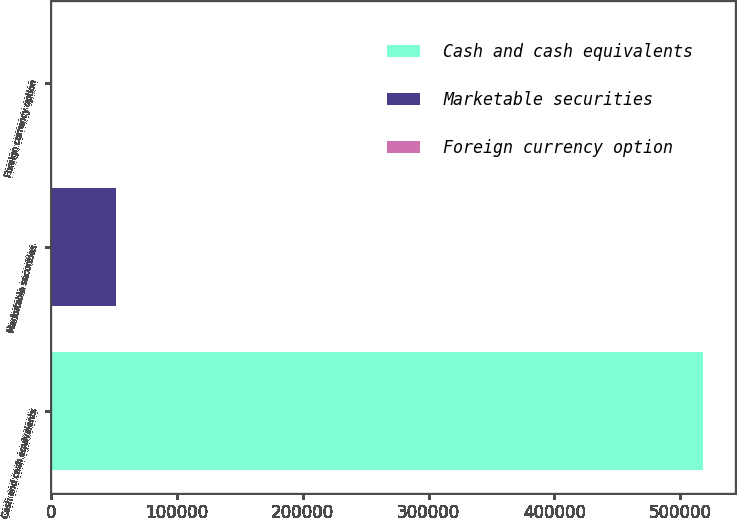<chart> <loc_0><loc_0><loc_500><loc_500><bar_chart><fcel>Cash and cash equivalents<fcel>Marketable securities<fcel>Foreign currency option<nl><fcel>517654<fcel>51948.1<fcel>203<nl></chart> 